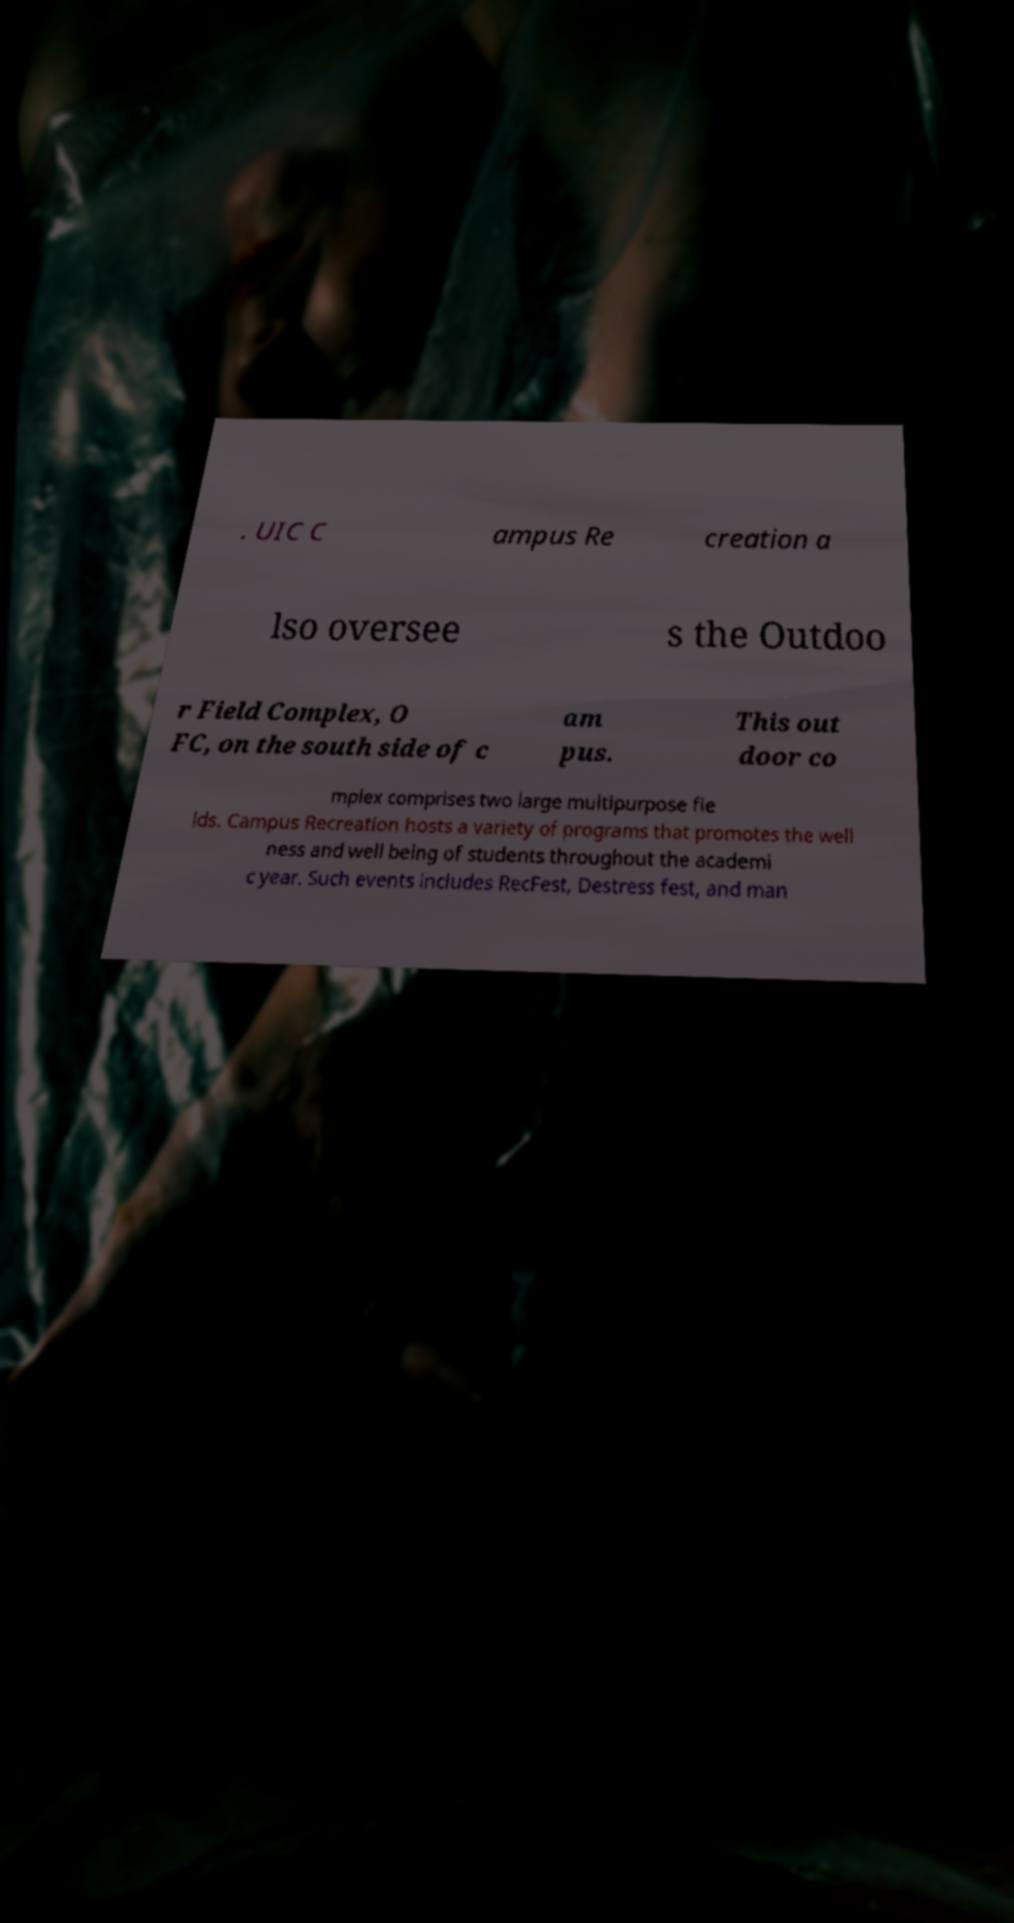Could you extract and type out the text from this image? . UIC C ampus Re creation a lso oversee s the Outdoo r Field Complex, O FC, on the south side of c am pus. This out door co mplex comprises two large multipurpose fie lds. Campus Recreation hosts a variety of programs that promotes the well ness and well being of students throughout the academi c year. Such events includes RecFest, Destress fest, and man 